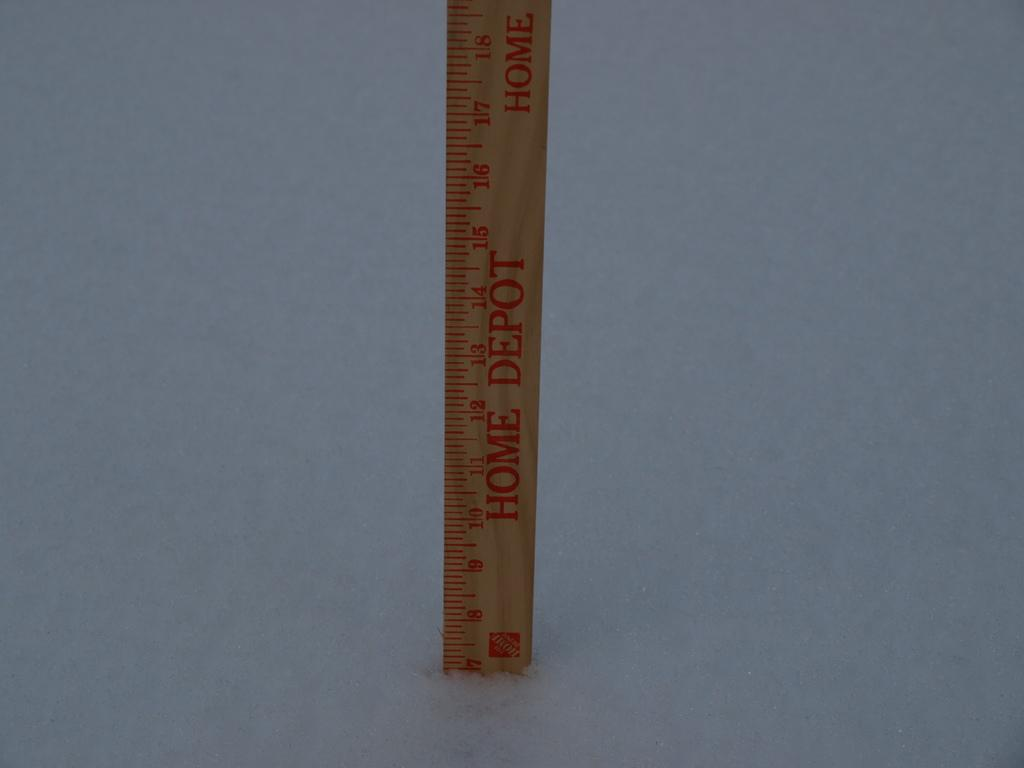<image>
Render a clear and concise summary of the photo. A wooden Home Depot ruler has been cut off around the 7 millimeter mark. 